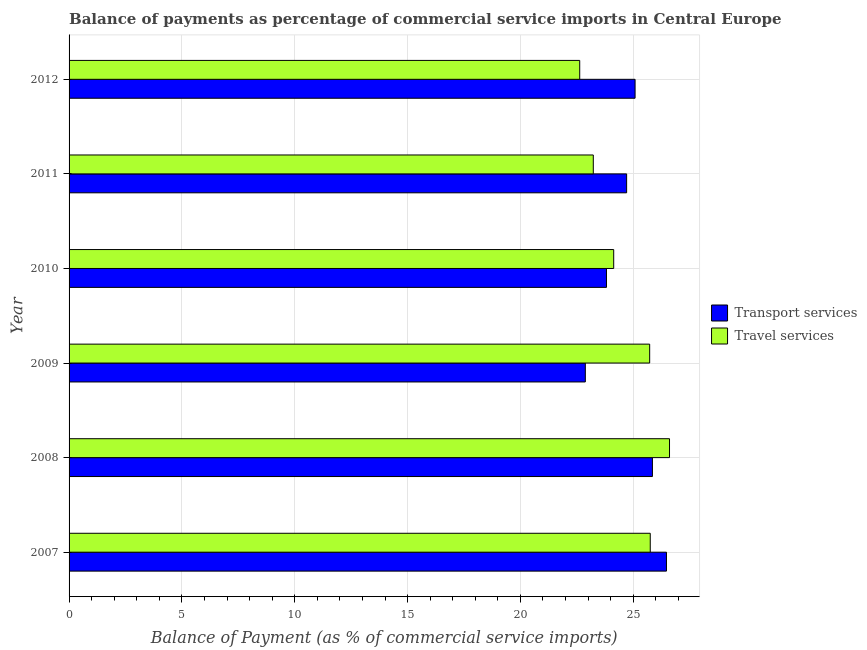Are the number of bars per tick equal to the number of legend labels?
Keep it short and to the point. Yes. Are the number of bars on each tick of the Y-axis equal?
Provide a short and direct response. Yes. What is the label of the 4th group of bars from the top?
Provide a short and direct response. 2009. In how many cases, is the number of bars for a given year not equal to the number of legend labels?
Your response must be concise. 0. What is the balance of payments of transport services in 2010?
Provide a succinct answer. 23.82. Across all years, what is the maximum balance of payments of travel services?
Provide a short and direct response. 26.61. Across all years, what is the minimum balance of payments of transport services?
Give a very brief answer. 22.88. In which year was the balance of payments of transport services maximum?
Your response must be concise. 2007. In which year was the balance of payments of transport services minimum?
Ensure brevity in your answer.  2009. What is the total balance of payments of travel services in the graph?
Offer a terse response. 148.09. What is the difference between the balance of payments of transport services in 2007 and that in 2011?
Ensure brevity in your answer.  1.77. What is the difference between the balance of payments of transport services in 2009 and the balance of payments of travel services in 2010?
Offer a terse response. -1.26. What is the average balance of payments of travel services per year?
Your answer should be compact. 24.68. In the year 2007, what is the difference between the balance of payments of transport services and balance of payments of travel services?
Provide a succinct answer. 0.72. In how many years, is the balance of payments of transport services greater than 7 %?
Your response must be concise. 6. What is the ratio of the balance of payments of transport services in 2007 to that in 2009?
Keep it short and to the point. 1.16. Is the difference between the balance of payments of travel services in 2007 and 2009 greater than the difference between the balance of payments of transport services in 2007 and 2009?
Make the answer very short. No. What is the difference between the highest and the second highest balance of payments of transport services?
Your answer should be very brief. 0.62. What is the difference between the highest and the lowest balance of payments of transport services?
Make the answer very short. 3.6. Is the sum of the balance of payments of travel services in 2009 and 2012 greater than the maximum balance of payments of transport services across all years?
Your answer should be compact. Yes. What does the 2nd bar from the top in 2007 represents?
Provide a short and direct response. Transport services. What does the 1st bar from the bottom in 2010 represents?
Offer a very short reply. Transport services. Are all the bars in the graph horizontal?
Offer a very short reply. Yes. Are the values on the major ticks of X-axis written in scientific E-notation?
Ensure brevity in your answer.  No. Does the graph contain any zero values?
Give a very brief answer. No. Does the graph contain grids?
Give a very brief answer. Yes. Where does the legend appear in the graph?
Make the answer very short. Center right. What is the title of the graph?
Your answer should be very brief. Balance of payments as percentage of commercial service imports in Central Europe. Does "% of GNI" appear as one of the legend labels in the graph?
Offer a terse response. No. What is the label or title of the X-axis?
Provide a short and direct response. Balance of Payment (as % of commercial service imports). What is the Balance of Payment (as % of commercial service imports) of Transport services in 2007?
Offer a terse response. 26.47. What is the Balance of Payment (as % of commercial service imports) of Travel services in 2007?
Your answer should be compact. 25.75. What is the Balance of Payment (as % of commercial service imports) of Transport services in 2008?
Provide a short and direct response. 25.85. What is the Balance of Payment (as % of commercial service imports) in Travel services in 2008?
Your response must be concise. 26.61. What is the Balance of Payment (as % of commercial service imports) in Transport services in 2009?
Offer a terse response. 22.88. What is the Balance of Payment (as % of commercial service imports) of Travel services in 2009?
Your answer should be very brief. 25.73. What is the Balance of Payment (as % of commercial service imports) in Transport services in 2010?
Keep it short and to the point. 23.82. What is the Balance of Payment (as % of commercial service imports) in Travel services in 2010?
Provide a succinct answer. 24.14. What is the Balance of Payment (as % of commercial service imports) of Transport services in 2011?
Ensure brevity in your answer.  24.71. What is the Balance of Payment (as % of commercial service imports) in Travel services in 2011?
Keep it short and to the point. 23.23. What is the Balance of Payment (as % of commercial service imports) in Transport services in 2012?
Offer a terse response. 25.08. What is the Balance of Payment (as % of commercial service imports) of Travel services in 2012?
Your response must be concise. 22.63. Across all years, what is the maximum Balance of Payment (as % of commercial service imports) in Transport services?
Your answer should be compact. 26.47. Across all years, what is the maximum Balance of Payment (as % of commercial service imports) of Travel services?
Give a very brief answer. 26.61. Across all years, what is the minimum Balance of Payment (as % of commercial service imports) of Transport services?
Make the answer very short. 22.88. Across all years, what is the minimum Balance of Payment (as % of commercial service imports) in Travel services?
Provide a succinct answer. 22.63. What is the total Balance of Payment (as % of commercial service imports) in Transport services in the graph?
Your answer should be very brief. 148.81. What is the total Balance of Payment (as % of commercial service imports) of Travel services in the graph?
Give a very brief answer. 148.09. What is the difference between the Balance of Payment (as % of commercial service imports) of Transport services in 2007 and that in 2008?
Provide a succinct answer. 0.62. What is the difference between the Balance of Payment (as % of commercial service imports) in Travel services in 2007 and that in 2008?
Provide a short and direct response. -0.85. What is the difference between the Balance of Payment (as % of commercial service imports) of Transport services in 2007 and that in 2009?
Keep it short and to the point. 3.6. What is the difference between the Balance of Payment (as % of commercial service imports) in Travel services in 2007 and that in 2009?
Your answer should be very brief. 0.03. What is the difference between the Balance of Payment (as % of commercial service imports) of Transport services in 2007 and that in 2010?
Provide a short and direct response. 2.66. What is the difference between the Balance of Payment (as % of commercial service imports) of Travel services in 2007 and that in 2010?
Give a very brief answer. 1.62. What is the difference between the Balance of Payment (as % of commercial service imports) of Transport services in 2007 and that in 2011?
Offer a very short reply. 1.77. What is the difference between the Balance of Payment (as % of commercial service imports) of Travel services in 2007 and that in 2011?
Your answer should be very brief. 2.52. What is the difference between the Balance of Payment (as % of commercial service imports) in Transport services in 2007 and that in 2012?
Make the answer very short. 1.39. What is the difference between the Balance of Payment (as % of commercial service imports) in Travel services in 2007 and that in 2012?
Offer a very short reply. 3.13. What is the difference between the Balance of Payment (as % of commercial service imports) of Transport services in 2008 and that in 2009?
Provide a short and direct response. 2.97. What is the difference between the Balance of Payment (as % of commercial service imports) in Travel services in 2008 and that in 2009?
Offer a very short reply. 0.88. What is the difference between the Balance of Payment (as % of commercial service imports) of Transport services in 2008 and that in 2010?
Offer a very short reply. 2.04. What is the difference between the Balance of Payment (as % of commercial service imports) of Travel services in 2008 and that in 2010?
Provide a succinct answer. 2.47. What is the difference between the Balance of Payment (as % of commercial service imports) in Transport services in 2008 and that in 2011?
Your answer should be very brief. 1.14. What is the difference between the Balance of Payment (as % of commercial service imports) in Travel services in 2008 and that in 2011?
Provide a succinct answer. 3.38. What is the difference between the Balance of Payment (as % of commercial service imports) of Transport services in 2008 and that in 2012?
Your answer should be very brief. 0.77. What is the difference between the Balance of Payment (as % of commercial service imports) in Travel services in 2008 and that in 2012?
Provide a succinct answer. 3.98. What is the difference between the Balance of Payment (as % of commercial service imports) in Transport services in 2009 and that in 2010?
Ensure brevity in your answer.  -0.94. What is the difference between the Balance of Payment (as % of commercial service imports) in Travel services in 2009 and that in 2010?
Your answer should be very brief. 1.59. What is the difference between the Balance of Payment (as % of commercial service imports) in Transport services in 2009 and that in 2011?
Offer a terse response. -1.83. What is the difference between the Balance of Payment (as % of commercial service imports) of Travel services in 2009 and that in 2011?
Offer a terse response. 2.5. What is the difference between the Balance of Payment (as % of commercial service imports) of Transport services in 2009 and that in 2012?
Offer a very short reply. -2.2. What is the difference between the Balance of Payment (as % of commercial service imports) of Travel services in 2009 and that in 2012?
Offer a very short reply. 3.1. What is the difference between the Balance of Payment (as % of commercial service imports) of Transport services in 2010 and that in 2011?
Give a very brief answer. -0.89. What is the difference between the Balance of Payment (as % of commercial service imports) of Travel services in 2010 and that in 2011?
Offer a very short reply. 0.9. What is the difference between the Balance of Payment (as % of commercial service imports) in Transport services in 2010 and that in 2012?
Offer a terse response. -1.27. What is the difference between the Balance of Payment (as % of commercial service imports) in Travel services in 2010 and that in 2012?
Your response must be concise. 1.51. What is the difference between the Balance of Payment (as % of commercial service imports) in Transport services in 2011 and that in 2012?
Your answer should be compact. -0.37. What is the difference between the Balance of Payment (as % of commercial service imports) in Travel services in 2011 and that in 2012?
Provide a succinct answer. 0.6. What is the difference between the Balance of Payment (as % of commercial service imports) in Transport services in 2007 and the Balance of Payment (as % of commercial service imports) in Travel services in 2008?
Offer a very short reply. -0.13. What is the difference between the Balance of Payment (as % of commercial service imports) in Transport services in 2007 and the Balance of Payment (as % of commercial service imports) in Travel services in 2009?
Make the answer very short. 0.74. What is the difference between the Balance of Payment (as % of commercial service imports) of Transport services in 2007 and the Balance of Payment (as % of commercial service imports) of Travel services in 2010?
Your response must be concise. 2.34. What is the difference between the Balance of Payment (as % of commercial service imports) of Transport services in 2007 and the Balance of Payment (as % of commercial service imports) of Travel services in 2011?
Offer a terse response. 3.24. What is the difference between the Balance of Payment (as % of commercial service imports) in Transport services in 2007 and the Balance of Payment (as % of commercial service imports) in Travel services in 2012?
Ensure brevity in your answer.  3.84. What is the difference between the Balance of Payment (as % of commercial service imports) in Transport services in 2008 and the Balance of Payment (as % of commercial service imports) in Travel services in 2009?
Keep it short and to the point. 0.12. What is the difference between the Balance of Payment (as % of commercial service imports) in Transport services in 2008 and the Balance of Payment (as % of commercial service imports) in Travel services in 2010?
Offer a very short reply. 1.72. What is the difference between the Balance of Payment (as % of commercial service imports) of Transport services in 2008 and the Balance of Payment (as % of commercial service imports) of Travel services in 2011?
Offer a terse response. 2.62. What is the difference between the Balance of Payment (as % of commercial service imports) of Transport services in 2008 and the Balance of Payment (as % of commercial service imports) of Travel services in 2012?
Make the answer very short. 3.22. What is the difference between the Balance of Payment (as % of commercial service imports) in Transport services in 2009 and the Balance of Payment (as % of commercial service imports) in Travel services in 2010?
Make the answer very short. -1.26. What is the difference between the Balance of Payment (as % of commercial service imports) of Transport services in 2009 and the Balance of Payment (as % of commercial service imports) of Travel services in 2011?
Keep it short and to the point. -0.35. What is the difference between the Balance of Payment (as % of commercial service imports) in Transport services in 2009 and the Balance of Payment (as % of commercial service imports) in Travel services in 2012?
Give a very brief answer. 0.25. What is the difference between the Balance of Payment (as % of commercial service imports) of Transport services in 2010 and the Balance of Payment (as % of commercial service imports) of Travel services in 2011?
Keep it short and to the point. 0.58. What is the difference between the Balance of Payment (as % of commercial service imports) of Transport services in 2010 and the Balance of Payment (as % of commercial service imports) of Travel services in 2012?
Offer a very short reply. 1.19. What is the difference between the Balance of Payment (as % of commercial service imports) in Transport services in 2011 and the Balance of Payment (as % of commercial service imports) in Travel services in 2012?
Give a very brief answer. 2.08. What is the average Balance of Payment (as % of commercial service imports) in Transport services per year?
Ensure brevity in your answer.  24.8. What is the average Balance of Payment (as % of commercial service imports) of Travel services per year?
Make the answer very short. 24.68. In the year 2007, what is the difference between the Balance of Payment (as % of commercial service imports) in Transport services and Balance of Payment (as % of commercial service imports) in Travel services?
Give a very brief answer. 0.72. In the year 2008, what is the difference between the Balance of Payment (as % of commercial service imports) of Transport services and Balance of Payment (as % of commercial service imports) of Travel services?
Your answer should be very brief. -0.76. In the year 2009, what is the difference between the Balance of Payment (as % of commercial service imports) of Transport services and Balance of Payment (as % of commercial service imports) of Travel services?
Make the answer very short. -2.85. In the year 2010, what is the difference between the Balance of Payment (as % of commercial service imports) in Transport services and Balance of Payment (as % of commercial service imports) in Travel services?
Provide a succinct answer. -0.32. In the year 2011, what is the difference between the Balance of Payment (as % of commercial service imports) in Transport services and Balance of Payment (as % of commercial service imports) in Travel services?
Ensure brevity in your answer.  1.48. In the year 2012, what is the difference between the Balance of Payment (as % of commercial service imports) of Transport services and Balance of Payment (as % of commercial service imports) of Travel services?
Your answer should be very brief. 2.45. What is the ratio of the Balance of Payment (as % of commercial service imports) in Transport services in 2007 to that in 2008?
Provide a short and direct response. 1.02. What is the ratio of the Balance of Payment (as % of commercial service imports) of Travel services in 2007 to that in 2008?
Keep it short and to the point. 0.97. What is the ratio of the Balance of Payment (as % of commercial service imports) of Transport services in 2007 to that in 2009?
Offer a very short reply. 1.16. What is the ratio of the Balance of Payment (as % of commercial service imports) of Transport services in 2007 to that in 2010?
Your answer should be very brief. 1.11. What is the ratio of the Balance of Payment (as % of commercial service imports) of Travel services in 2007 to that in 2010?
Make the answer very short. 1.07. What is the ratio of the Balance of Payment (as % of commercial service imports) of Transport services in 2007 to that in 2011?
Give a very brief answer. 1.07. What is the ratio of the Balance of Payment (as % of commercial service imports) in Travel services in 2007 to that in 2011?
Offer a very short reply. 1.11. What is the ratio of the Balance of Payment (as % of commercial service imports) in Transport services in 2007 to that in 2012?
Offer a very short reply. 1.06. What is the ratio of the Balance of Payment (as % of commercial service imports) in Travel services in 2007 to that in 2012?
Your response must be concise. 1.14. What is the ratio of the Balance of Payment (as % of commercial service imports) of Transport services in 2008 to that in 2009?
Provide a succinct answer. 1.13. What is the ratio of the Balance of Payment (as % of commercial service imports) in Travel services in 2008 to that in 2009?
Give a very brief answer. 1.03. What is the ratio of the Balance of Payment (as % of commercial service imports) in Transport services in 2008 to that in 2010?
Provide a succinct answer. 1.09. What is the ratio of the Balance of Payment (as % of commercial service imports) in Travel services in 2008 to that in 2010?
Your answer should be compact. 1.1. What is the ratio of the Balance of Payment (as % of commercial service imports) of Transport services in 2008 to that in 2011?
Keep it short and to the point. 1.05. What is the ratio of the Balance of Payment (as % of commercial service imports) in Travel services in 2008 to that in 2011?
Offer a very short reply. 1.15. What is the ratio of the Balance of Payment (as % of commercial service imports) of Transport services in 2008 to that in 2012?
Make the answer very short. 1.03. What is the ratio of the Balance of Payment (as % of commercial service imports) of Travel services in 2008 to that in 2012?
Ensure brevity in your answer.  1.18. What is the ratio of the Balance of Payment (as % of commercial service imports) of Transport services in 2009 to that in 2010?
Offer a very short reply. 0.96. What is the ratio of the Balance of Payment (as % of commercial service imports) of Travel services in 2009 to that in 2010?
Offer a terse response. 1.07. What is the ratio of the Balance of Payment (as % of commercial service imports) in Transport services in 2009 to that in 2011?
Keep it short and to the point. 0.93. What is the ratio of the Balance of Payment (as % of commercial service imports) in Travel services in 2009 to that in 2011?
Your answer should be compact. 1.11. What is the ratio of the Balance of Payment (as % of commercial service imports) of Transport services in 2009 to that in 2012?
Your response must be concise. 0.91. What is the ratio of the Balance of Payment (as % of commercial service imports) in Travel services in 2009 to that in 2012?
Your answer should be very brief. 1.14. What is the ratio of the Balance of Payment (as % of commercial service imports) of Transport services in 2010 to that in 2011?
Give a very brief answer. 0.96. What is the ratio of the Balance of Payment (as % of commercial service imports) in Travel services in 2010 to that in 2011?
Ensure brevity in your answer.  1.04. What is the ratio of the Balance of Payment (as % of commercial service imports) in Transport services in 2010 to that in 2012?
Provide a succinct answer. 0.95. What is the ratio of the Balance of Payment (as % of commercial service imports) in Travel services in 2010 to that in 2012?
Ensure brevity in your answer.  1.07. What is the ratio of the Balance of Payment (as % of commercial service imports) in Transport services in 2011 to that in 2012?
Offer a very short reply. 0.99. What is the ratio of the Balance of Payment (as % of commercial service imports) of Travel services in 2011 to that in 2012?
Your response must be concise. 1.03. What is the difference between the highest and the second highest Balance of Payment (as % of commercial service imports) in Transport services?
Provide a short and direct response. 0.62. What is the difference between the highest and the second highest Balance of Payment (as % of commercial service imports) in Travel services?
Keep it short and to the point. 0.85. What is the difference between the highest and the lowest Balance of Payment (as % of commercial service imports) of Transport services?
Keep it short and to the point. 3.6. What is the difference between the highest and the lowest Balance of Payment (as % of commercial service imports) of Travel services?
Your answer should be very brief. 3.98. 